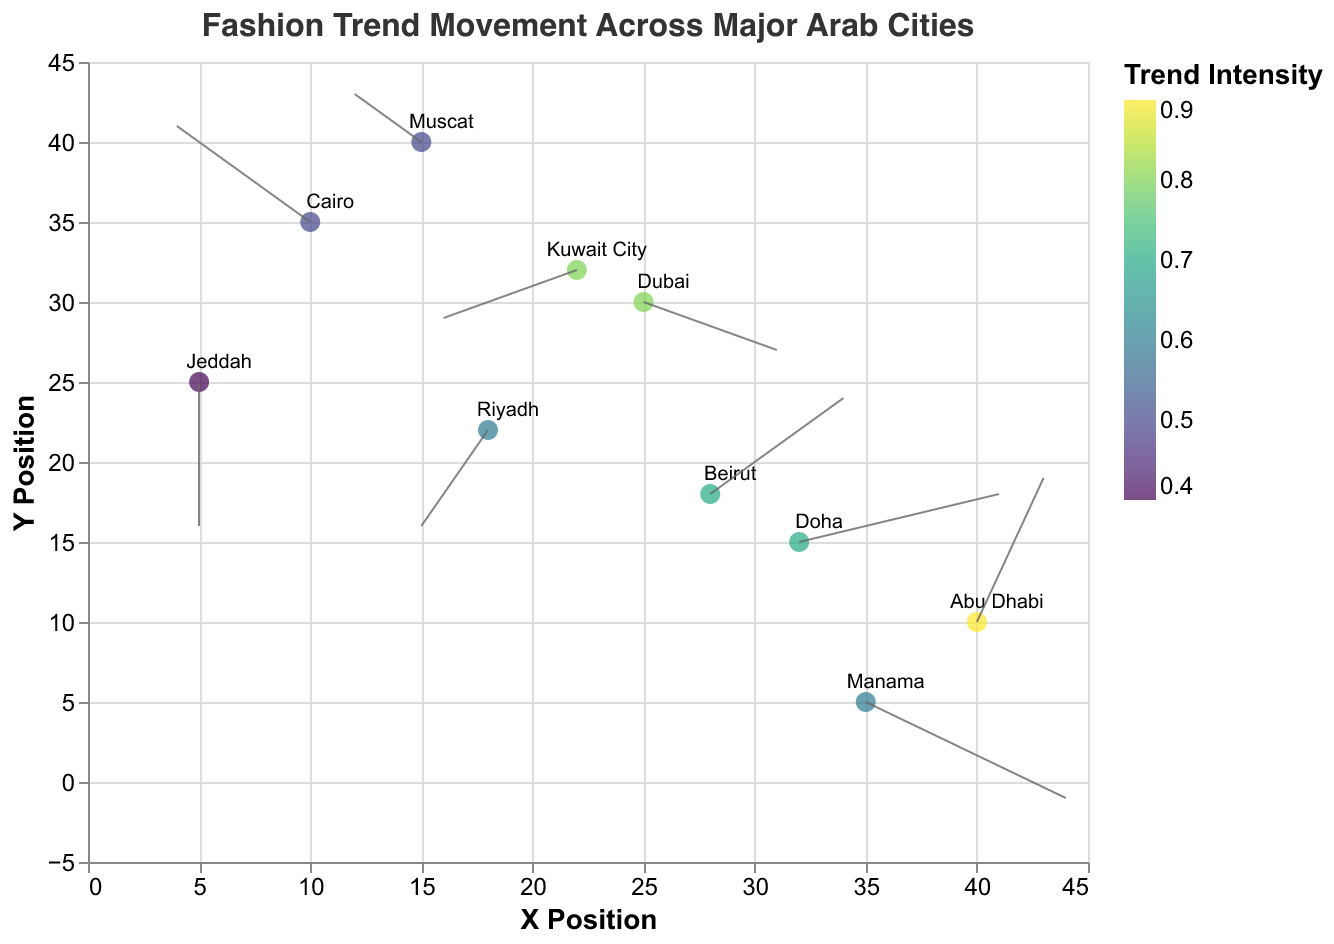What is the title of the figure? The title is located at the top of the figure, it states the subject of the visualization. It reads "Fashion Trend Movement Across Major Arab Cities."
Answer: "Fashion Trend Movement Across Major Arab Cities" Which city shows the highest trend intensity? The color legend indicates that higher trend intensity is represented by colors closer to the top of the viridis scale. Abu Dhabi, marked in a shade representing 0.9, has the highest trend intensity.
Answer: Abu Dhabi How many cities have their trends moving in the negative y-direction? The arrow directions need to be checked for each city to see if the v component is negative. There are four cities: Dubai (-1), Riyadh (-2), Jeddah (-3), and Kuwait City (-1) with trends moving in the negative y-direction.
Answer: 4 Which city shows the largest horizontal trend movement? This is determined by the largest positive or negative u component. Manama and Doha both have the largest horizontal movement with a u component of 3.
Answer: Manama and Doha Between Beirut and Muscat, which city has a stronger trend intensity? Comparing the trend intensity values and the corresponding color shades, Beirut has a trend intensity of 0.7, while Muscat has 0.5. Therefore, Beirut's trend intensity is stronger.
Answer: Beirut What is the direction of the trend in Dubai? The trend direction is given by the u and v components. In Dubai, the trend is moving 2 units right (positive x direction) and 1 unit down (negative y direction).
Answer: 2 units right and 1 unit down Among the cities Riyadh and Cairo, which one has the trend moving more vertically? We need to compare the absolute values of the v components. Riyadh's v is -2, and Cairo's v is 2, both having the same magnitude.
Answer: Both have the same vertical movement Which city shows a strictly downward trend? We need to identify any city where the trend direction only has a negative v component and zero u component. Jeddah has a downward trend with a v component of -3 and u component of 0.
Answer: Jeddah What is the average trend intensity of Doha and Beirut? Adding the trend intensity values of Doha (0.7) and Beirut (0.7) gives a total of 1.4. Dividing this by 2, the average trend intensity is 0.7.
Answer: 0.7 Which city exhibits a trend direction of 3 units in the positive x direction and 1 unit in the positive y direction? We need to find the city with u = 3 and v = 1. Doha's trend direction fits this description.
Answer: Doha 